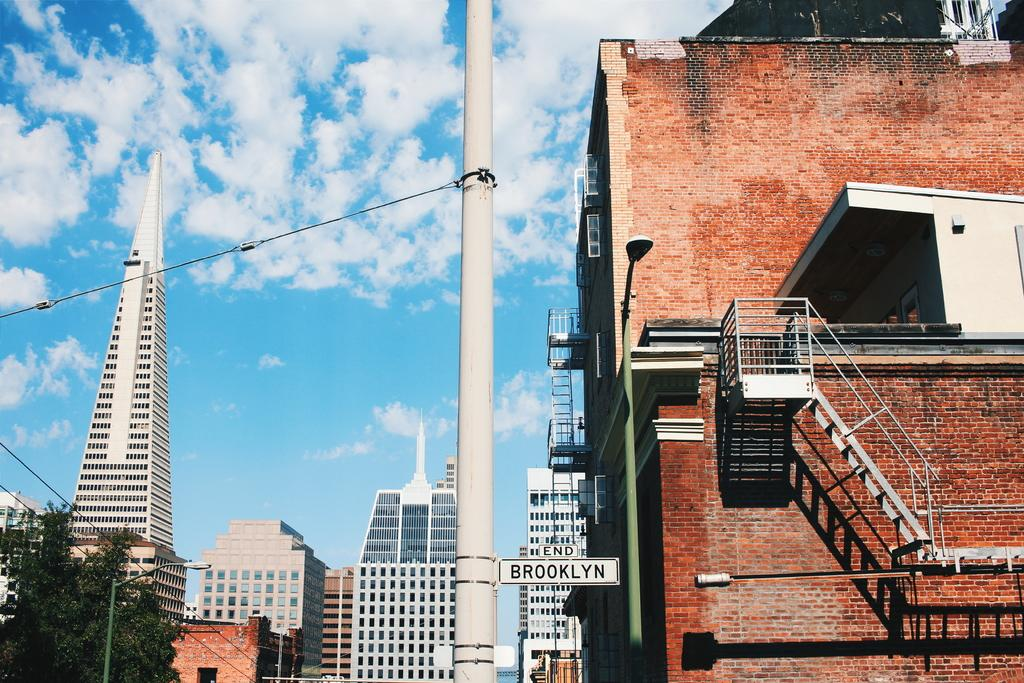What type of structures are present in the image? There is a group of buildings in the image. What features can be observed on the buildings? The buildings have windows and stairs. What other objects can be seen in the image? There are street poles, a name board, and wires connected to a pole in the image. What is visible in the sky in the image? The sky is visible in the image, and it appears cloudy. What type of magic is being performed by the buildings in the image? There is no magic being performed by the buildings in the image; they are simply structures with windows and stairs. What type of pipe is connected to the wires in the image? There is: There is no pipe connected to the wires in the image; only wires are visible. 